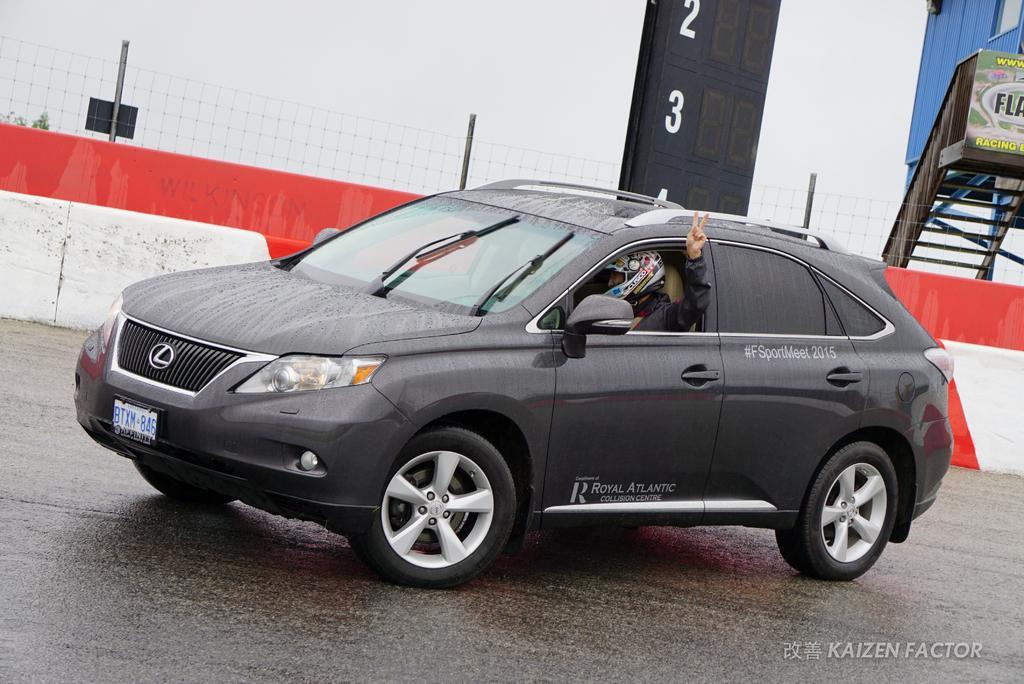How would you summarize this image in a sentence or two? In the middle of the image we can see a car on the road and a person is seated in it, in the background we can see few metal rods, fence and a hoarding, in the bottom right hand corner we can see some text. 